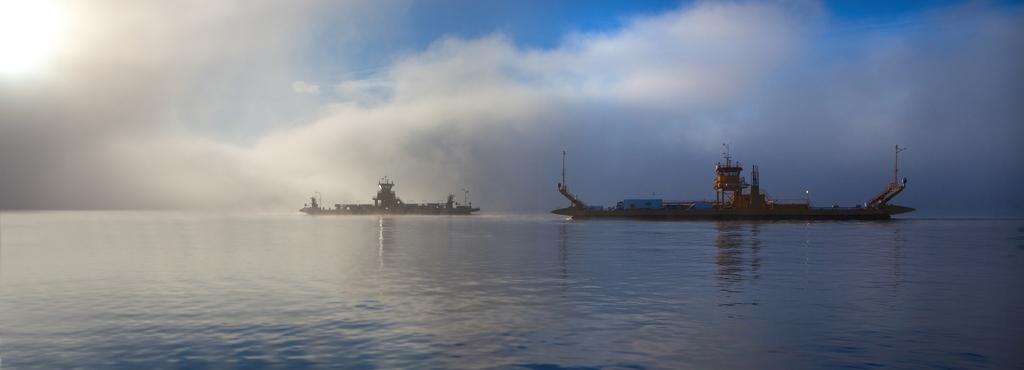What can be seen in the image? There are two ships in the image. Where are the ships located? The ships are on the water. What is the color of the sky in the background? The sky in the background is blue and white. What type of line is connecting the two ships in the image? There is no line connecting the two ships in the image. What utensil can be seen being used by the crew on the ships? There are no utensils visible in the image, as it features two ships on the water with no crew or additional objects. 